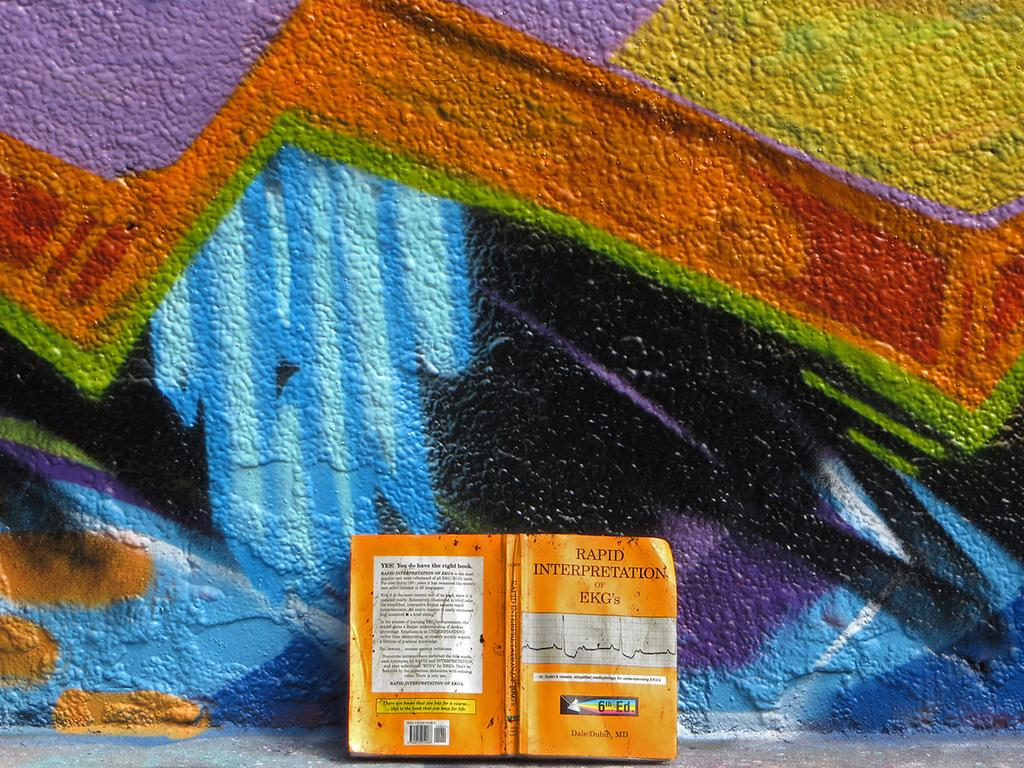What object can be seen in the image? There is a book in the image. What type of background is visible in the image? There is a painted wall in the image. Is there a secretary sitting next to the book in the image? There is no secretary present in the image. What type of outdoor shelter can be seen in the image? There is no tent or any outdoor shelter present in the image. 